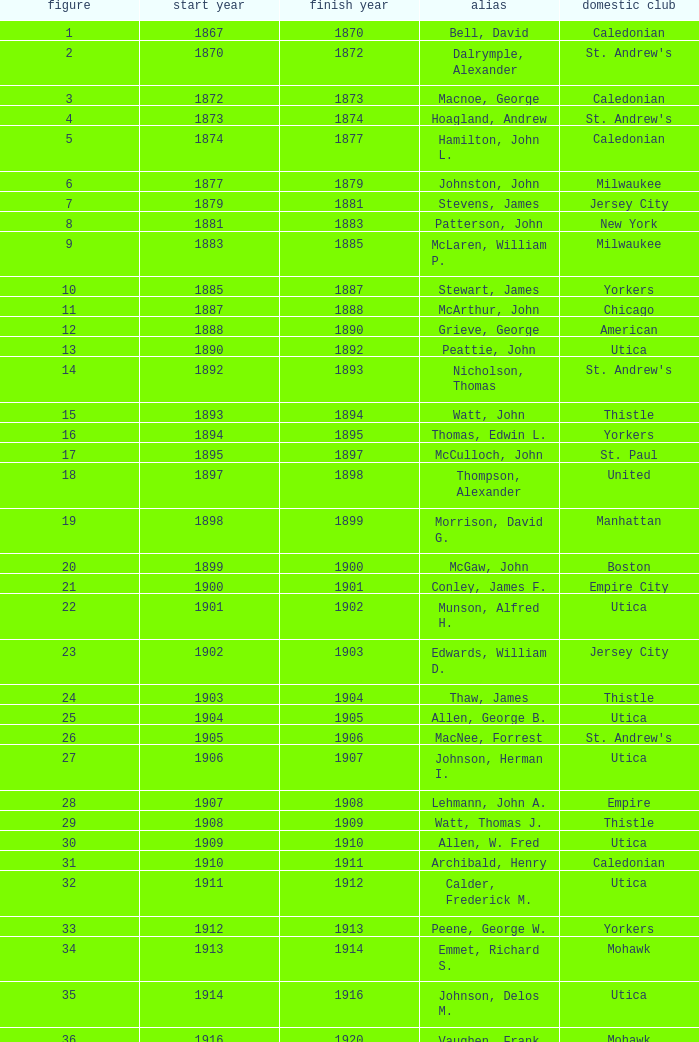Which Number has a Home Club of broomstones, and a Year End smaller than 1999? None. 